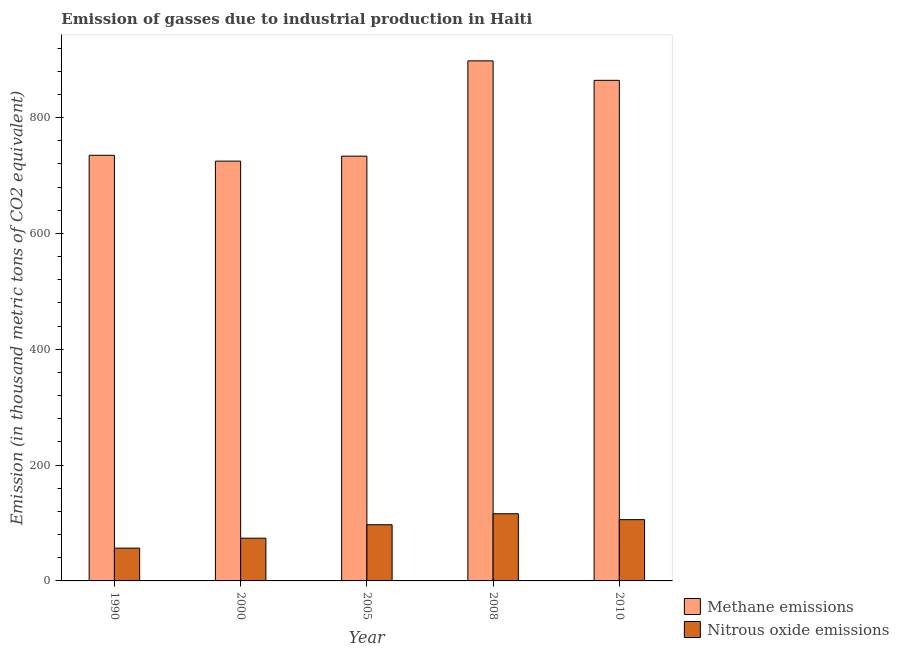How many groups of bars are there?
Offer a terse response. 5. Are the number of bars per tick equal to the number of legend labels?
Keep it short and to the point. Yes. Are the number of bars on each tick of the X-axis equal?
Ensure brevity in your answer.  Yes. How many bars are there on the 1st tick from the right?
Your answer should be compact. 2. What is the label of the 3rd group of bars from the left?
Give a very brief answer. 2005. In how many cases, is the number of bars for a given year not equal to the number of legend labels?
Offer a very short reply. 0. What is the amount of nitrous oxide emissions in 2010?
Your response must be concise. 105.8. Across all years, what is the maximum amount of methane emissions?
Keep it short and to the point. 897.9. Across all years, what is the minimum amount of methane emissions?
Your answer should be compact. 724.8. What is the total amount of methane emissions in the graph?
Provide a short and direct response. 3955.3. What is the difference between the amount of nitrous oxide emissions in 1990 and that in 2000?
Ensure brevity in your answer.  -17.2. What is the difference between the amount of methane emissions in 2000 and the amount of nitrous oxide emissions in 2010?
Your response must be concise. -139.5. What is the average amount of nitrous oxide emissions per year?
Ensure brevity in your answer.  89.84. In how many years, is the amount of methane emissions greater than 840 thousand metric tons?
Offer a terse response. 2. What is the ratio of the amount of nitrous oxide emissions in 2000 to that in 2008?
Your response must be concise. 0.64. Is the amount of methane emissions in 1990 less than that in 2000?
Your answer should be compact. No. Is the difference between the amount of methane emissions in 2008 and 2010 greater than the difference between the amount of nitrous oxide emissions in 2008 and 2010?
Make the answer very short. No. What is the difference between the highest and the second highest amount of methane emissions?
Keep it short and to the point. 33.6. What is the difference between the highest and the lowest amount of methane emissions?
Offer a terse response. 173.1. Is the sum of the amount of nitrous oxide emissions in 2000 and 2008 greater than the maximum amount of methane emissions across all years?
Offer a terse response. Yes. What does the 1st bar from the left in 2000 represents?
Your response must be concise. Methane emissions. What does the 1st bar from the right in 2010 represents?
Your response must be concise. Nitrous oxide emissions. How many bars are there?
Your answer should be compact. 10. Are all the bars in the graph horizontal?
Provide a succinct answer. No. What is the difference between two consecutive major ticks on the Y-axis?
Your response must be concise. 200. Does the graph contain any zero values?
Keep it short and to the point. No. Where does the legend appear in the graph?
Make the answer very short. Bottom right. How many legend labels are there?
Your response must be concise. 2. How are the legend labels stacked?
Provide a succinct answer. Vertical. What is the title of the graph?
Provide a succinct answer. Emission of gasses due to industrial production in Haiti. What is the label or title of the Y-axis?
Offer a very short reply. Emission (in thousand metric tons of CO2 equivalent). What is the Emission (in thousand metric tons of CO2 equivalent) of Methane emissions in 1990?
Offer a terse response. 734.9. What is the Emission (in thousand metric tons of CO2 equivalent) of Nitrous oxide emissions in 1990?
Provide a succinct answer. 56.6. What is the Emission (in thousand metric tons of CO2 equivalent) in Methane emissions in 2000?
Your response must be concise. 724.8. What is the Emission (in thousand metric tons of CO2 equivalent) in Nitrous oxide emissions in 2000?
Keep it short and to the point. 73.8. What is the Emission (in thousand metric tons of CO2 equivalent) in Methane emissions in 2005?
Ensure brevity in your answer.  733.4. What is the Emission (in thousand metric tons of CO2 equivalent) in Nitrous oxide emissions in 2005?
Your answer should be very brief. 97. What is the Emission (in thousand metric tons of CO2 equivalent) in Methane emissions in 2008?
Ensure brevity in your answer.  897.9. What is the Emission (in thousand metric tons of CO2 equivalent) in Nitrous oxide emissions in 2008?
Your answer should be very brief. 116. What is the Emission (in thousand metric tons of CO2 equivalent) of Methane emissions in 2010?
Give a very brief answer. 864.3. What is the Emission (in thousand metric tons of CO2 equivalent) of Nitrous oxide emissions in 2010?
Your answer should be compact. 105.8. Across all years, what is the maximum Emission (in thousand metric tons of CO2 equivalent) in Methane emissions?
Give a very brief answer. 897.9. Across all years, what is the maximum Emission (in thousand metric tons of CO2 equivalent) of Nitrous oxide emissions?
Offer a terse response. 116. Across all years, what is the minimum Emission (in thousand metric tons of CO2 equivalent) of Methane emissions?
Your answer should be very brief. 724.8. Across all years, what is the minimum Emission (in thousand metric tons of CO2 equivalent) of Nitrous oxide emissions?
Your answer should be compact. 56.6. What is the total Emission (in thousand metric tons of CO2 equivalent) of Methane emissions in the graph?
Provide a succinct answer. 3955.3. What is the total Emission (in thousand metric tons of CO2 equivalent) in Nitrous oxide emissions in the graph?
Your answer should be very brief. 449.2. What is the difference between the Emission (in thousand metric tons of CO2 equivalent) in Nitrous oxide emissions in 1990 and that in 2000?
Give a very brief answer. -17.2. What is the difference between the Emission (in thousand metric tons of CO2 equivalent) in Methane emissions in 1990 and that in 2005?
Keep it short and to the point. 1.5. What is the difference between the Emission (in thousand metric tons of CO2 equivalent) in Nitrous oxide emissions in 1990 and that in 2005?
Your answer should be compact. -40.4. What is the difference between the Emission (in thousand metric tons of CO2 equivalent) in Methane emissions in 1990 and that in 2008?
Your answer should be compact. -163. What is the difference between the Emission (in thousand metric tons of CO2 equivalent) of Nitrous oxide emissions in 1990 and that in 2008?
Make the answer very short. -59.4. What is the difference between the Emission (in thousand metric tons of CO2 equivalent) of Methane emissions in 1990 and that in 2010?
Your answer should be compact. -129.4. What is the difference between the Emission (in thousand metric tons of CO2 equivalent) in Nitrous oxide emissions in 1990 and that in 2010?
Make the answer very short. -49.2. What is the difference between the Emission (in thousand metric tons of CO2 equivalent) in Methane emissions in 2000 and that in 2005?
Provide a succinct answer. -8.6. What is the difference between the Emission (in thousand metric tons of CO2 equivalent) in Nitrous oxide emissions in 2000 and that in 2005?
Provide a short and direct response. -23.2. What is the difference between the Emission (in thousand metric tons of CO2 equivalent) in Methane emissions in 2000 and that in 2008?
Offer a terse response. -173.1. What is the difference between the Emission (in thousand metric tons of CO2 equivalent) of Nitrous oxide emissions in 2000 and that in 2008?
Your response must be concise. -42.2. What is the difference between the Emission (in thousand metric tons of CO2 equivalent) of Methane emissions in 2000 and that in 2010?
Offer a terse response. -139.5. What is the difference between the Emission (in thousand metric tons of CO2 equivalent) of Nitrous oxide emissions in 2000 and that in 2010?
Your answer should be compact. -32. What is the difference between the Emission (in thousand metric tons of CO2 equivalent) in Methane emissions in 2005 and that in 2008?
Ensure brevity in your answer.  -164.5. What is the difference between the Emission (in thousand metric tons of CO2 equivalent) in Nitrous oxide emissions in 2005 and that in 2008?
Provide a short and direct response. -19. What is the difference between the Emission (in thousand metric tons of CO2 equivalent) in Methane emissions in 2005 and that in 2010?
Offer a terse response. -130.9. What is the difference between the Emission (in thousand metric tons of CO2 equivalent) of Nitrous oxide emissions in 2005 and that in 2010?
Provide a succinct answer. -8.8. What is the difference between the Emission (in thousand metric tons of CO2 equivalent) of Methane emissions in 2008 and that in 2010?
Ensure brevity in your answer.  33.6. What is the difference between the Emission (in thousand metric tons of CO2 equivalent) of Methane emissions in 1990 and the Emission (in thousand metric tons of CO2 equivalent) of Nitrous oxide emissions in 2000?
Make the answer very short. 661.1. What is the difference between the Emission (in thousand metric tons of CO2 equivalent) of Methane emissions in 1990 and the Emission (in thousand metric tons of CO2 equivalent) of Nitrous oxide emissions in 2005?
Provide a succinct answer. 637.9. What is the difference between the Emission (in thousand metric tons of CO2 equivalent) in Methane emissions in 1990 and the Emission (in thousand metric tons of CO2 equivalent) in Nitrous oxide emissions in 2008?
Ensure brevity in your answer.  618.9. What is the difference between the Emission (in thousand metric tons of CO2 equivalent) of Methane emissions in 1990 and the Emission (in thousand metric tons of CO2 equivalent) of Nitrous oxide emissions in 2010?
Provide a short and direct response. 629.1. What is the difference between the Emission (in thousand metric tons of CO2 equivalent) of Methane emissions in 2000 and the Emission (in thousand metric tons of CO2 equivalent) of Nitrous oxide emissions in 2005?
Offer a terse response. 627.8. What is the difference between the Emission (in thousand metric tons of CO2 equivalent) of Methane emissions in 2000 and the Emission (in thousand metric tons of CO2 equivalent) of Nitrous oxide emissions in 2008?
Offer a terse response. 608.8. What is the difference between the Emission (in thousand metric tons of CO2 equivalent) of Methane emissions in 2000 and the Emission (in thousand metric tons of CO2 equivalent) of Nitrous oxide emissions in 2010?
Keep it short and to the point. 619. What is the difference between the Emission (in thousand metric tons of CO2 equivalent) in Methane emissions in 2005 and the Emission (in thousand metric tons of CO2 equivalent) in Nitrous oxide emissions in 2008?
Make the answer very short. 617.4. What is the difference between the Emission (in thousand metric tons of CO2 equivalent) in Methane emissions in 2005 and the Emission (in thousand metric tons of CO2 equivalent) in Nitrous oxide emissions in 2010?
Your answer should be very brief. 627.6. What is the difference between the Emission (in thousand metric tons of CO2 equivalent) in Methane emissions in 2008 and the Emission (in thousand metric tons of CO2 equivalent) in Nitrous oxide emissions in 2010?
Offer a terse response. 792.1. What is the average Emission (in thousand metric tons of CO2 equivalent) of Methane emissions per year?
Keep it short and to the point. 791.06. What is the average Emission (in thousand metric tons of CO2 equivalent) of Nitrous oxide emissions per year?
Offer a terse response. 89.84. In the year 1990, what is the difference between the Emission (in thousand metric tons of CO2 equivalent) in Methane emissions and Emission (in thousand metric tons of CO2 equivalent) in Nitrous oxide emissions?
Offer a very short reply. 678.3. In the year 2000, what is the difference between the Emission (in thousand metric tons of CO2 equivalent) of Methane emissions and Emission (in thousand metric tons of CO2 equivalent) of Nitrous oxide emissions?
Your answer should be very brief. 651. In the year 2005, what is the difference between the Emission (in thousand metric tons of CO2 equivalent) in Methane emissions and Emission (in thousand metric tons of CO2 equivalent) in Nitrous oxide emissions?
Your response must be concise. 636.4. In the year 2008, what is the difference between the Emission (in thousand metric tons of CO2 equivalent) of Methane emissions and Emission (in thousand metric tons of CO2 equivalent) of Nitrous oxide emissions?
Your response must be concise. 781.9. In the year 2010, what is the difference between the Emission (in thousand metric tons of CO2 equivalent) in Methane emissions and Emission (in thousand metric tons of CO2 equivalent) in Nitrous oxide emissions?
Your answer should be compact. 758.5. What is the ratio of the Emission (in thousand metric tons of CO2 equivalent) of Methane emissions in 1990 to that in 2000?
Offer a very short reply. 1.01. What is the ratio of the Emission (in thousand metric tons of CO2 equivalent) in Nitrous oxide emissions in 1990 to that in 2000?
Make the answer very short. 0.77. What is the ratio of the Emission (in thousand metric tons of CO2 equivalent) in Nitrous oxide emissions in 1990 to that in 2005?
Make the answer very short. 0.58. What is the ratio of the Emission (in thousand metric tons of CO2 equivalent) in Methane emissions in 1990 to that in 2008?
Provide a short and direct response. 0.82. What is the ratio of the Emission (in thousand metric tons of CO2 equivalent) in Nitrous oxide emissions in 1990 to that in 2008?
Make the answer very short. 0.49. What is the ratio of the Emission (in thousand metric tons of CO2 equivalent) in Methane emissions in 1990 to that in 2010?
Make the answer very short. 0.85. What is the ratio of the Emission (in thousand metric tons of CO2 equivalent) of Nitrous oxide emissions in 1990 to that in 2010?
Give a very brief answer. 0.54. What is the ratio of the Emission (in thousand metric tons of CO2 equivalent) of Methane emissions in 2000 to that in 2005?
Offer a very short reply. 0.99. What is the ratio of the Emission (in thousand metric tons of CO2 equivalent) of Nitrous oxide emissions in 2000 to that in 2005?
Offer a terse response. 0.76. What is the ratio of the Emission (in thousand metric tons of CO2 equivalent) in Methane emissions in 2000 to that in 2008?
Offer a very short reply. 0.81. What is the ratio of the Emission (in thousand metric tons of CO2 equivalent) of Nitrous oxide emissions in 2000 to that in 2008?
Provide a succinct answer. 0.64. What is the ratio of the Emission (in thousand metric tons of CO2 equivalent) in Methane emissions in 2000 to that in 2010?
Your response must be concise. 0.84. What is the ratio of the Emission (in thousand metric tons of CO2 equivalent) in Nitrous oxide emissions in 2000 to that in 2010?
Your answer should be very brief. 0.7. What is the ratio of the Emission (in thousand metric tons of CO2 equivalent) of Methane emissions in 2005 to that in 2008?
Give a very brief answer. 0.82. What is the ratio of the Emission (in thousand metric tons of CO2 equivalent) in Nitrous oxide emissions in 2005 to that in 2008?
Offer a very short reply. 0.84. What is the ratio of the Emission (in thousand metric tons of CO2 equivalent) in Methane emissions in 2005 to that in 2010?
Ensure brevity in your answer.  0.85. What is the ratio of the Emission (in thousand metric tons of CO2 equivalent) of Nitrous oxide emissions in 2005 to that in 2010?
Provide a short and direct response. 0.92. What is the ratio of the Emission (in thousand metric tons of CO2 equivalent) in Methane emissions in 2008 to that in 2010?
Make the answer very short. 1.04. What is the ratio of the Emission (in thousand metric tons of CO2 equivalent) in Nitrous oxide emissions in 2008 to that in 2010?
Provide a succinct answer. 1.1. What is the difference between the highest and the second highest Emission (in thousand metric tons of CO2 equivalent) in Methane emissions?
Provide a succinct answer. 33.6. What is the difference between the highest and the lowest Emission (in thousand metric tons of CO2 equivalent) in Methane emissions?
Your answer should be compact. 173.1. What is the difference between the highest and the lowest Emission (in thousand metric tons of CO2 equivalent) of Nitrous oxide emissions?
Your answer should be compact. 59.4. 